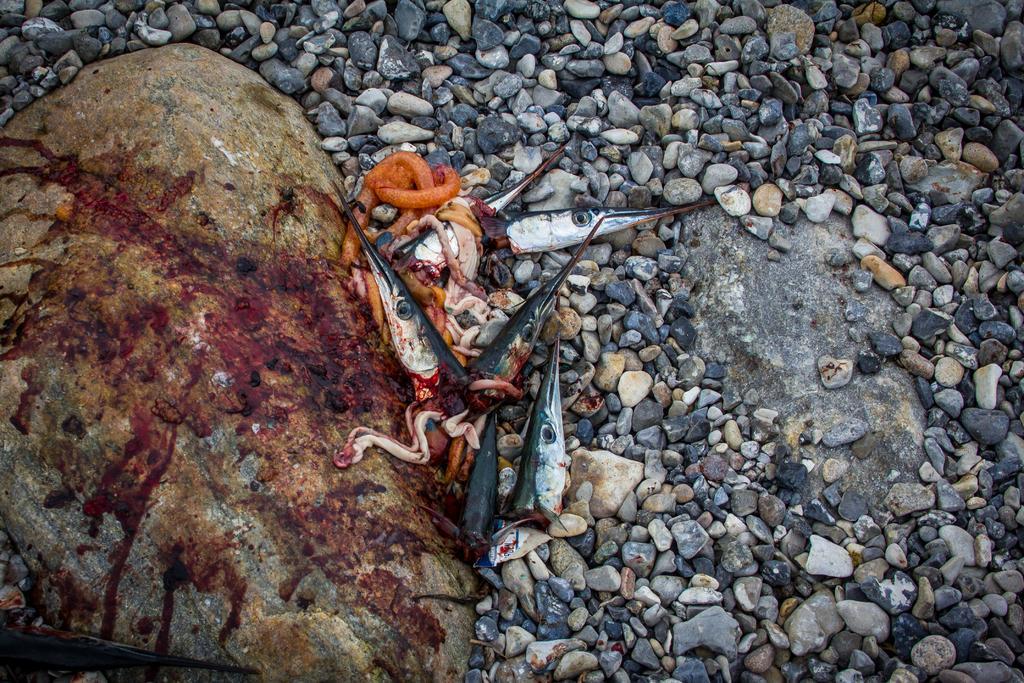In one or two sentences, can you explain what this image depicts? In this image we can see some waste parts of the fish. We can also see some blood on the rock and some stones. 